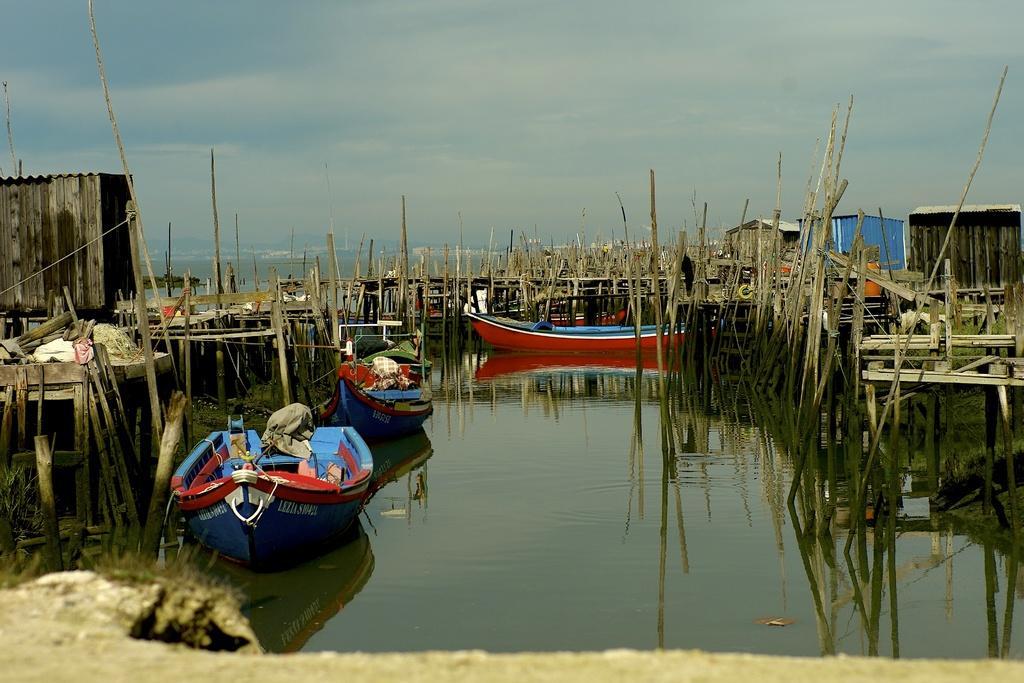Can you describe this image briefly? In this image I can see water and on it I can see three boats. I can also see number of clothes on these boats. I can also see number of wooden poles shacks and in the background I can see clouds and the sky. 